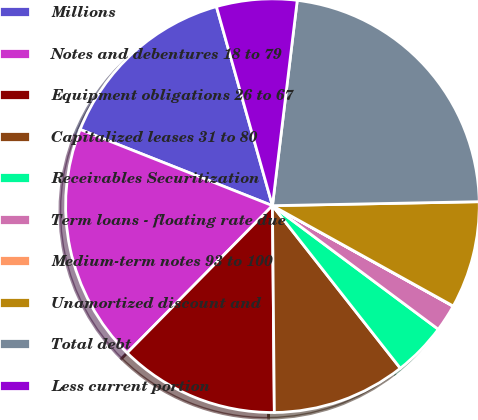Convert chart. <chart><loc_0><loc_0><loc_500><loc_500><pie_chart><fcel>Millions<fcel>Notes and debentures 18 to 79<fcel>Equipment obligations 26 to 67<fcel>Capitalized leases 31 to 80<fcel>Receivables Securitization<fcel>Term loans - floating rate due<fcel>Medium-term notes 93 to 100<fcel>Unamortized discount and<fcel>Total debt<fcel>Less current portion<nl><fcel>14.63%<fcel>18.61%<fcel>12.54%<fcel>10.46%<fcel>4.2%<fcel>2.11%<fcel>0.02%<fcel>8.37%<fcel>22.78%<fcel>6.28%<nl></chart> 